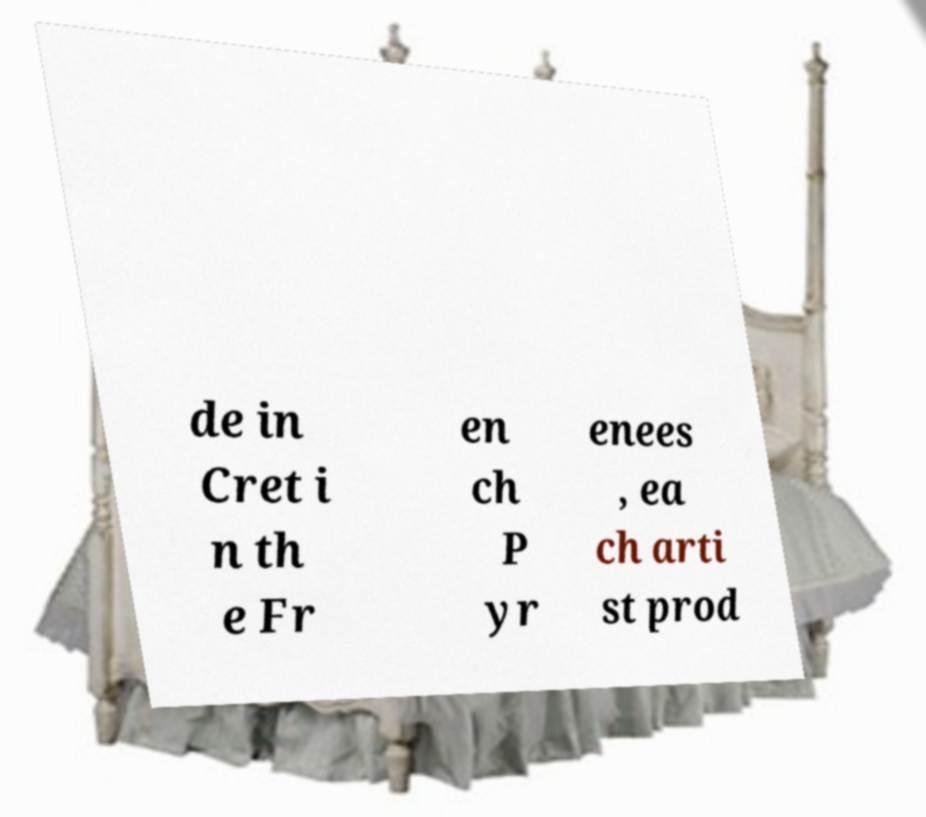Can you read and provide the text displayed in the image?This photo seems to have some interesting text. Can you extract and type it out for me? de in Cret i n th e Fr en ch P yr enees , ea ch arti st prod 